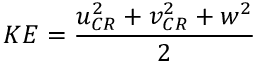Convert formula to latex. <formula><loc_0><loc_0><loc_500><loc_500>K E = \frac { u _ { C R } ^ { 2 } + v _ { C R } ^ { 2 } + w ^ { 2 } } { 2 }</formula> 